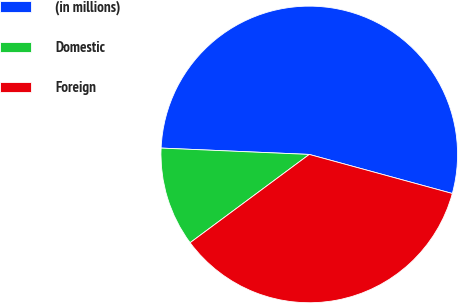<chart> <loc_0><loc_0><loc_500><loc_500><pie_chart><fcel>(in millions)<fcel>Domestic<fcel>Foreign<nl><fcel>53.56%<fcel>10.83%<fcel>35.61%<nl></chart> 